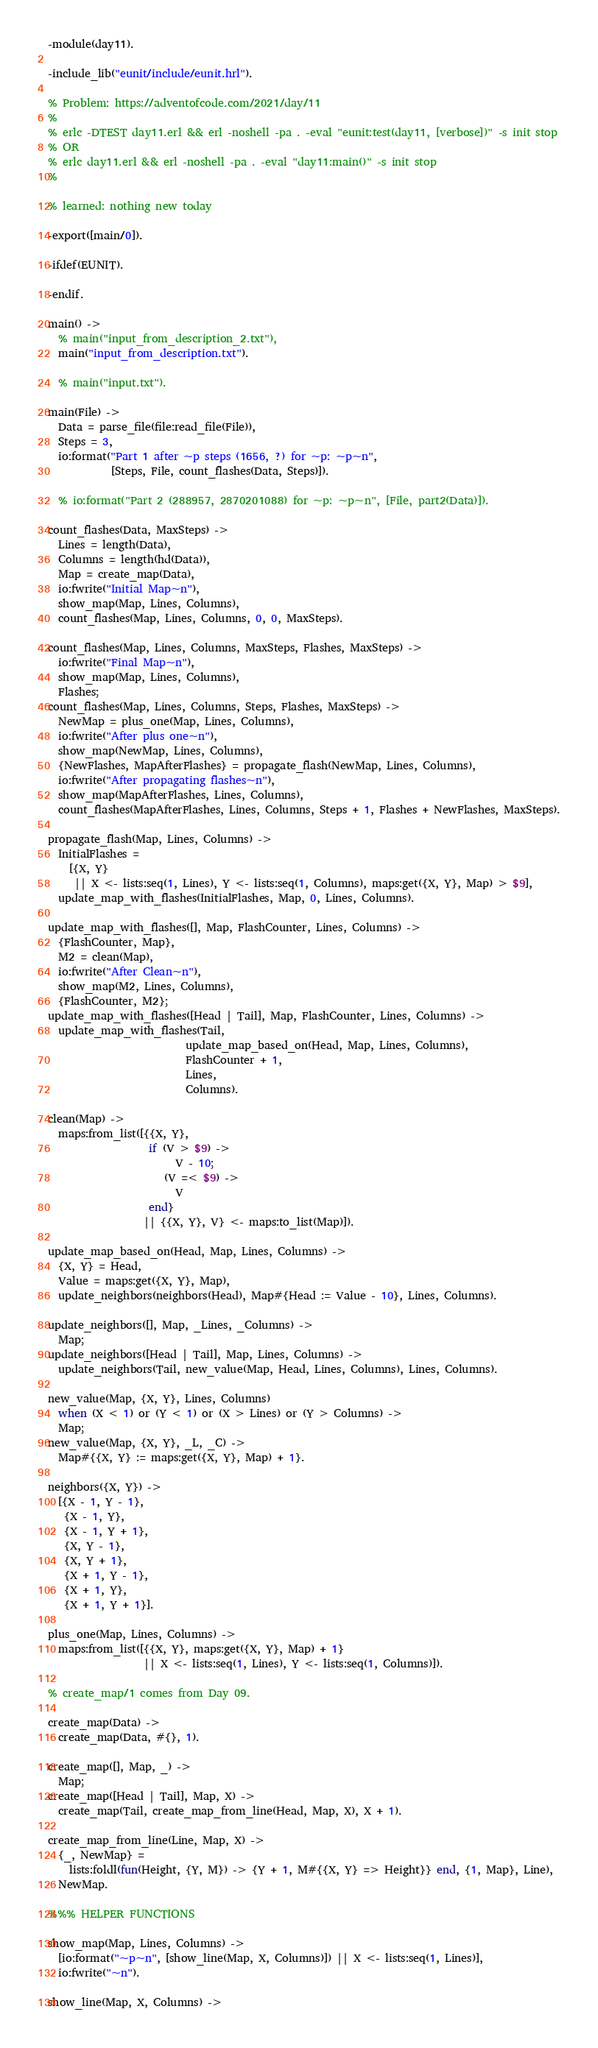<code> <loc_0><loc_0><loc_500><loc_500><_Erlang_>-module(day11).

-include_lib("eunit/include/eunit.hrl").

% Problem: https://adventofcode.com/2021/day/11
%
% erlc -DTEST day11.erl && erl -noshell -pa . -eval "eunit:test(day11, [verbose])" -s init stop
% OR
% erlc day11.erl && erl -noshell -pa . -eval "day11:main()" -s init stop
%

% learned: nothing new today

-export([main/0]).

-ifdef(EUNIT).

-endif.

main() ->
  % main("input_from_description_2.txt"),
  main("input_from_description.txt").

  % main("input.txt").

main(File) ->
  Data = parse_file(file:read_file(File)),
  Steps = 3,
  io:format("Part 1 after ~p steps (1656, ?) for ~p: ~p~n",
            [Steps, File, count_flashes(Data, Steps)]).

  % io:format("Part 2 (288957, 2870201088) for ~p: ~p~n", [File, part2(Data)]).

count_flashes(Data, MaxSteps) ->
  Lines = length(Data),
  Columns = length(hd(Data)),
  Map = create_map(Data),
  io:fwrite("Initial Map~n"),
  show_map(Map, Lines, Columns),
  count_flashes(Map, Lines, Columns, 0, 0, MaxSteps).

count_flashes(Map, Lines, Columns, MaxSteps, Flashes, MaxSteps) ->
  io:fwrite("Final Map~n"),
  show_map(Map, Lines, Columns),
  Flashes;
count_flashes(Map, Lines, Columns, Steps, Flashes, MaxSteps) ->
  NewMap = plus_one(Map, Lines, Columns),
  io:fwrite("After plus one~n"),
  show_map(NewMap, Lines, Columns),
  {NewFlashes, MapAfterFlashes} = propagate_flash(NewMap, Lines, Columns),
  io:fwrite("After propagating flashes~n"),
  show_map(MapAfterFlashes, Lines, Columns),
  count_flashes(MapAfterFlashes, Lines, Columns, Steps + 1, Flashes + NewFlashes, MaxSteps).

propagate_flash(Map, Lines, Columns) ->
  InitialFlashes =
    [{X, Y}
     || X <- lists:seq(1, Lines), Y <- lists:seq(1, Columns), maps:get({X, Y}, Map) > $9],
  update_map_with_flashes(InitialFlashes, Map, 0, Lines, Columns).

update_map_with_flashes([], Map, FlashCounter, Lines, Columns) ->
  {FlashCounter, Map},
  M2 = clean(Map),
  io:fwrite("After Clean~n"),
  show_map(M2, Lines, Columns),
  {FlashCounter, M2};
update_map_with_flashes([Head | Tail], Map, FlashCounter, Lines, Columns) ->
  update_map_with_flashes(Tail,
                          update_map_based_on(Head, Map, Lines, Columns),
                          FlashCounter + 1,
                          Lines,
                          Columns).

clean(Map) ->
  maps:from_list([{{X, Y},
                   if (V > $9) ->
                        V - 10;
                      (V =< $9) ->
                        V
                   end}
                  || {{X, Y}, V} <- maps:to_list(Map)]).

update_map_based_on(Head, Map, Lines, Columns) ->
  {X, Y} = Head,
  Value = maps:get({X, Y}, Map),
  update_neighbors(neighbors(Head), Map#{Head := Value - 10}, Lines, Columns).

update_neighbors([], Map, _Lines, _Columns) ->
  Map;
update_neighbors([Head | Tail], Map, Lines, Columns) ->
  update_neighbors(Tail, new_value(Map, Head, Lines, Columns), Lines, Columns).

new_value(Map, {X, Y}, Lines, Columns)
  when (X < 1) or (Y < 1) or (X > Lines) or (Y > Columns) ->
  Map;
new_value(Map, {X, Y}, _L, _C) ->
  Map#{{X, Y} := maps:get({X, Y}, Map) + 1}.

neighbors({X, Y}) ->
  [{X - 1, Y - 1},
   {X - 1, Y},
   {X - 1, Y + 1},
   {X, Y - 1},
   {X, Y + 1},
   {X + 1, Y - 1},
   {X + 1, Y},
   {X + 1, Y + 1}].

plus_one(Map, Lines, Columns) ->
  maps:from_list([{{X, Y}, maps:get({X, Y}, Map) + 1}
                  || X <- lists:seq(1, Lines), Y <- lists:seq(1, Columns)]).

% create_map/1 comes from Day 09.

create_map(Data) ->
  create_map(Data, #{}, 1).

create_map([], Map, _) ->
  Map;
create_map([Head | Tail], Map, X) ->
  create_map(Tail, create_map_from_line(Head, Map, X), X + 1).

create_map_from_line(Line, Map, X) ->
  {_, NewMap} =
    lists:foldl(fun(Height, {Y, M}) -> {Y + 1, M#{{X, Y} => Height}} end, {1, Map}, Line),
  NewMap.

%%% HELPER FUNCTIONS

show_map(Map, Lines, Columns) ->
  [io:format("~p~n", [show_line(Map, X, Columns)]) || X <- lists:seq(1, Lines)],
  io:fwrite("~n").

show_line(Map, X, Columns) -></code> 